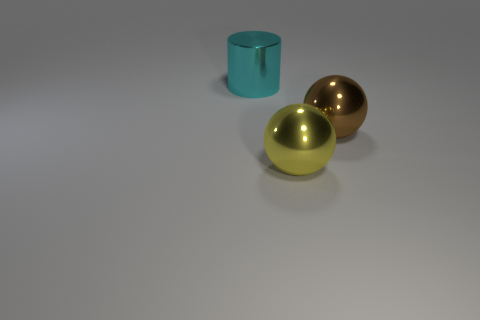Add 2 tiny brown matte cylinders. How many objects exist? 5 Subtract 1 spheres. How many spheres are left? 1 Subtract all brown cylinders. Subtract all gray blocks. How many cylinders are left? 1 Subtract all purple cylinders. How many yellow balls are left? 1 Subtract all yellow shiny objects. Subtract all large brown metal objects. How many objects are left? 1 Add 3 large yellow balls. How many large yellow balls are left? 4 Add 2 small blue matte cylinders. How many small blue matte cylinders exist? 2 Subtract all brown spheres. How many spheres are left? 1 Subtract 0 purple blocks. How many objects are left? 3 Subtract all cylinders. How many objects are left? 2 